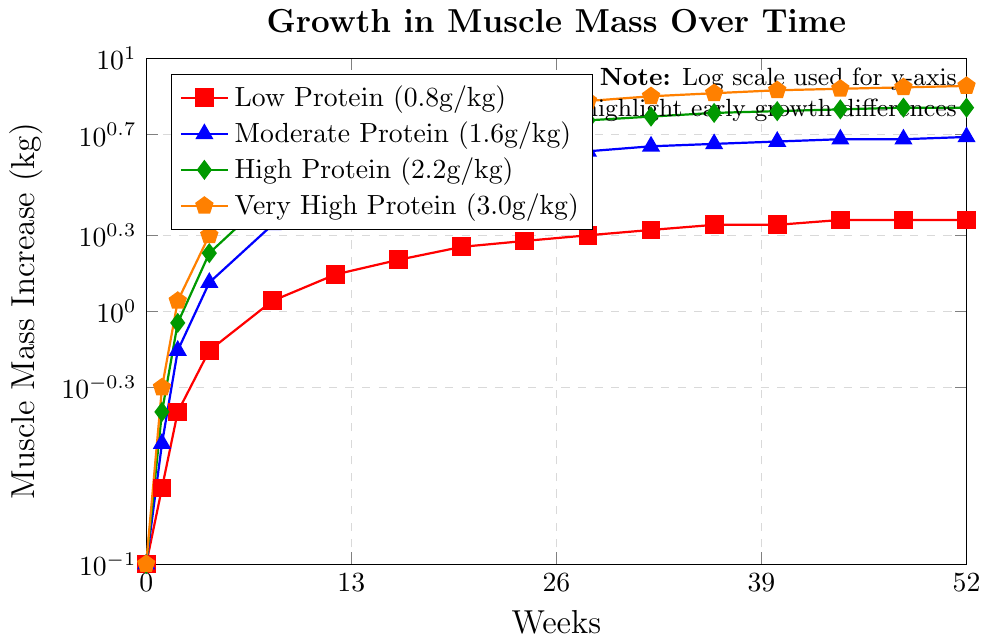what's the highest muscle mass increase for the Very High Protein group? The Very High Protein group's data points show a maximum muscle mass increase at week 52, which is 7.8 kg.
Answer: 7.8 kg which protein intake level resulted in the least muscle mass increase at week 12? At week 12, the Low Protein group shows the lowest muscle mass increase at 1.4 kg.
Answer: Low Protein By how many kilograms did the muscle mass increase for the Moderate Protein group from week 0 to week 8? At week 0, the Moderate Protein group's muscle mass increase is 0 kg. At week 8, it is 2.2 kg. The difference is 2.2 kg - 0 kg = 2.2 kg.
Answer: 2.2 kg which protein intake level had the steepest initial growth in muscle mass? By looking at the initial few weeks, the Very High Protein group shows the steepest increase from 0.1 kg at week 0 to 0.5 kg at week 1.
Answer: Very High Protein what is the average muscle mass increase for the High Protein group over the first 4 weeks? The High Protein group's muscle mass increases for weeks 0, 1, 2, and 4 are: 0, 0.4, 0.9, and 1.7 kg. The average is (0 + 0.4 + 0.9 + 1.7)/4 = 0.75 kg.
Answer: 0.75 kg at week 20, how much greater is the muscle mass increase for the High Protein group compared to the Low Protein group? At week 20, the High Protein group's increase is 5.0 kg, while the Low Protein group’s increase is 1.8 kg. The difference is 5.0 kg - 1.8 kg = 3.2 kg.
Answer: 3.2 kg how does the muscle mass increase for the Moderate Protein and Very High Protein groups compare at week 32? At week 32, the Moderate Protein group shows an increase of 4.5 kg, while the Very High Protein group shows an increase of 7.1 kg. The Very High Protein group's increase is greater.
Answer: Very High Protein group From weeks 24 to 52, which protein intake group shows the least change in muscle mass increase? The Low Protein group increases from 1.9 kg to 2.3 kg, a change of 0.4 kg. The Moderate Protein group changes from 4.1 kg to 4.9 kg, a change of 0.8 kg. The High Protein group changes from 5.4 kg to 6.4 kg, a change of 1.0 kg. The Very High Protein group changes from 6.4 kg to 7.8 kg, a change of 1.4 kg. Hence, the Low Protein group shows the least change at 0.4 kg.
Answer: Low Protein what’s the muscle mass increase difference between the Low Protein and Moderate Protein groups at week 16? The Low Protein group's increase at week 16 is 1.6 kg, while the Moderate Protein group's increase is 3.4 kg. The difference is 3.4 kg - 1.6 kg = 1.8 kg.
Answer: 1.8 kg 